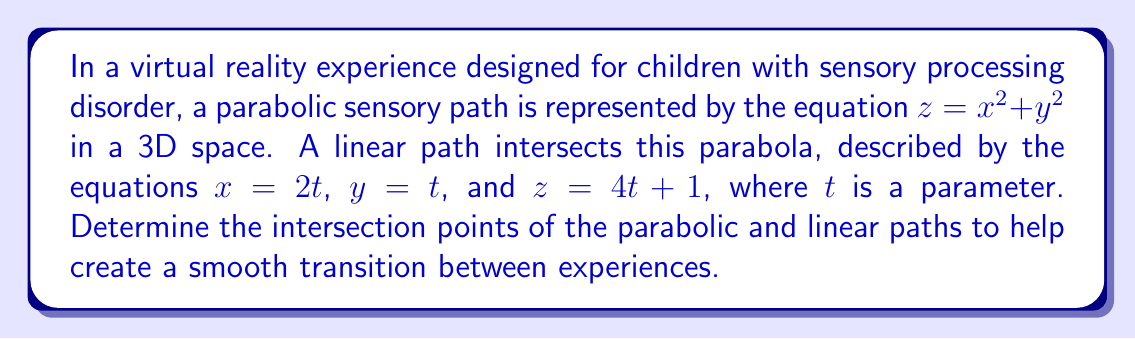Provide a solution to this math problem. Let's approach this step-by-step:

1) The parabola is given by:
   $z = x^2 + y^2$

2) The line is parametrically defined as:
   $x = 2t$
   $y = t$
   $z = 4t + 1$

3) To find the intersection, we need to substitute the line equations into the parabola equation:
   $4t + 1 = (2t)^2 + t^2$

4) Simplify the right side:
   $4t + 1 = 4t^2 + t^2 = 5t^2$

5) Rearrange the equation:
   $5t^2 - 4t - 1 = 0$

6) This is a quadratic equation. We can solve it using the quadratic formula:
   $t = \frac{-b \pm \sqrt{b^2 - 4ac}}{2a}$

   Where $a = 5$, $b = -4$, and $c = -1$

7) Substituting these values:
   $t = \frac{4 \pm \sqrt{16 + 20}}{10} = \frac{4 \pm \sqrt{36}}{10} = \frac{4 \pm 6}{10}$

8) This gives us two solutions:
   $t_1 = \frac{4 + 6}{10} = 1$
   $t_2 = \frac{4 - 6}{10} = -\frac{1}{5}$

9) Now, we can find the intersection points by substituting these t-values back into the line equations:

   For $t_1 = 1$:
   $x = 2(1) = 2$
   $y = 1$
   $z = 4(1) + 1 = 5$

   For $t_2 = -\frac{1}{5}$:
   $x = 2(-\frac{1}{5}) = -\frac{2}{5}$
   $y = -\frac{1}{5}$
   $z = 4(-\frac{1}{5}) + 1 = \frac{1}{5}$

Therefore, the intersection points are $(2, 1, 5)$ and $(-\frac{2}{5}, -\frac{1}{5}, \frac{1}{5})$.
Answer: $(2, 1, 5)$ and $(-\frac{2}{5}, -\frac{1}{5}, \frac{1}{5})$ 